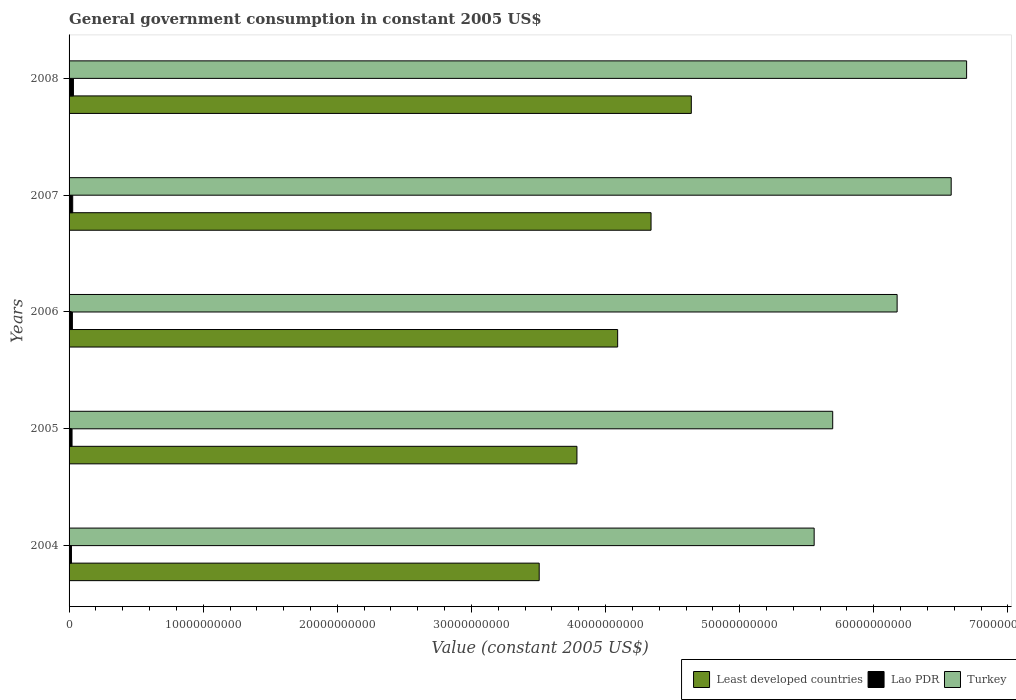How many different coloured bars are there?
Provide a short and direct response. 3. How many groups of bars are there?
Your answer should be very brief. 5. Are the number of bars on each tick of the Y-axis equal?
Your answer should be very brief. Yes. How many bars are there on the 4th tick from the bottom?
Provide a short and direct response. 3. What is the label of the 5th group of bars from the top?
Make the answer very short. 2004. In how many cases, is the number of bars for a given year not equal to the number of legend labels?
Your answer should be very brief. 0. What is the government conusmption in Least developed countries in 2004?
Give a very brief answer. 3.51e+1. Across all years, what is the maximum government conusmption in Least developed countries?
Make the answer very short. 4.64e+1. Across all years, what is the minimum government conusmption in Turkey?
Offer a very short reply. 5.56e+1. In which year was the government conusmption in Least developed countries maximum?
Offer a terse response. 2008. What is the total government conusmption in Turkey in the graph?
Ensure brevity in your answer.  3.07e+11. What is the difference between the government conusmption in Turkey in 2004 and that in 2008?
Your answer should be compact. -1.14e+1. What is the difference between the government conusmption in Least developed countries in 2004 and the government conusmption in Lao PDR in 2008?
Keep it short and to the point. 3.47e+1. What is the average government conusmption in Least developed countries per year?
Offer a terse response. 4.07e+1. In the year 2006, what is the difference between the government conusmption in Turkey and government conusmption in Least developed countries?
Ensure brevity in your answer.  2.08e+1. In how many years, is the government conusmption in Lao PDR greater than 6000000000 US$?
Your response must be concise. 0. What is the ratio of the government conusmption in Least developed countries in 2006 to that in 2007?
Make the answer very short. 0.94. What is the difference between the highest and the second highest government conusmption in Turkey?
Your answer should be very brief. 1.15e+09. What is the difference between the highest and the lowest government conusmption in Lao PDR?
Give a very brief answer. 1.46e+08. In how many years, is the government conusmption in Lao PDR greater than the average government conusmption in Lao PDR taken over all years?
Your answer should be very brief. 2. Is the sum of the government conusmption in Turkey in 2005 and 2008 greater than the maximum government conusmption in Least developed countries across all years?
Provide a succinct answer. Yes. What does the 3rd bar from the top in 2005 represents?
Provide a short and direct response. Least developed countries. What does the 1st bar from the bottom in 2004 represents?
Your response must be concise. Least developed countries. Is it the case that in every year, the sum of the government conusmption in Turkey and government conusmption in Least developed countries is greater than the government conusmption in Lao PDR?
Ensure brevity in your answer.  Yes. How many bars are there?
Provide a succinct answer. 15. What is the title of the graph?
Make the answer very short. General government consumption in constant 2005 US$. What is the label or title of the X-axis?
Your answer should be compact. Value (constant 2005 US$). What is the label or title of the Y-axis?
Give a very brief answer. Years. What is the Value (constant 2005 US$) in Least developed countries in 2004?
Make the answer very short. 3.51e+1. What is the Value (constant 2005 US$) in Lao PDR in 2004?
Provide a short and direct response. 1.79e+08. What is the Value (constant 2005 US$) in Turkey in 2004?
Offer a terse response. 5.56e+1. What is the Value (constant 2005 US$) of Least developed countries in 2005?
Make the answer very short. 3.79e+1. What is the Value (constant 2005 US$) of Lao PDR in 2005?
Give a very brief answer. 2.22e+08. What is the Value (constant 2005 US$) of Turkey in 2005?
Give a very brief answer. 5.69e+1. What is the Value (constant 2005 US$) of Least developed countries in 2006?
Your answer should be very brief. 4.09e+1. What is the Value (constant 2005 US$) in Lao PDR in 2006?
Keep it short and to the point. 2.48e+08. What is the Value (constant 2005 US$) of Turkey in 2006?
Offer a very short reply. 6.17e+1. What is the Value (constant 2005 US$) of Least developed countries in 2007?
Offer a terse response. 4.34e+1. What is the Value (constant 2005 US$) in Lao PDR in 2007?
Keep it short and to the point. 2.70e+08. What is the Value (constant 2005 US$) in Turkey in 2007?
Offer a very short reply. 6.58e+1. What is the Value (constant 2005 US$) of Least developed countries in 2008?
Ensure brevity in your answer.  4.64e+1. What is the Value (constant 2005 US$) of Lao PDR in 2008?
Your answer should be very brief. 3.25e+08. What is the Value (constant 2005 US$) in Turkey in 2008?
Your answer should be very brief. 6.69e+1. Across all years, what is the maximum Value (constant 2005 US$) of Least developed countries?
Your answer should be compact. 4.64e+1. Across all years, what is the maximum Value (constant 2005 US$) in Lao PDR?
Provide a short and direct response. 3.25e+08. Across all years, what is the maximum Value (constant 2005 US$) of Turkey?
Your answer should be very brief. 6.69e+1. Across all years, what is the minimum Value (constant 2005 US$) of Least developed countries?
Offer a very short reply. 3.51e+1. Across all years, what is the minimum Value (constant 2005 US$) in Lao PDR?
Ensure brevity in your answer.  1.79e+08. Across all years, what is the minimum Value (constant 2005 US$) of Turkey?
Give a very brief answer. 5.56e+1. What is the total Value (constant 2005 US$) of Least developed countries in the graph?
Give a very brief answer. 2.04e+11. What is the total Value (constant 2005 US$) of Lao PDR in the graph?
Your answer should be very brief. 1.24e+09. What is the total Value (constant 2005 US$) of Turkey in the graph?
Provide a short and direct response. 3.07e+11. What is the difference between the Value (constant 2005 US$) in Least developed countries in 2004 and that in 2005?
Offer a terse response. -2.81e+09. What is the difference between the Value (constant 2005 US$) in Lao PDR in 2004 and that in 2005?
Offer a very short reply. -4.29e+07. What is the difference between the Value (constant 2005 US$) of Turkey in 2004 and that in 2005?
Your answer should be very brief. -1.38e+09. What is the difference between the Value (constant 2005 US$) of Least developed countries in 2004 and that in 2006?
Your response must be concise. -5.85e+09. What is the difference between the Value (constant 2005 US$) of Lao PDR in 2004 and that in 2006?
Your response must be concise. -6.93e+07. What is the difference between the Value (constant 2005 US$) of Turkey in 2004 and that in 2006?
Give a very brief answer. -6.19e+09. What is the difference between the Value (constant 2005 US$) of Least developed countries in 2004 and that in 2007?
Give a very brief answer. -8.34e+09. What is the difference between the Value (constant 2005 US$) of Lao PDR in 2004 and that in 2007?
Give a very brief answer. -9.17e+07. What is the difference between the Value (constant 2005 US$) in Turkey in 2004 and that in 2007?
Ensure brevity in your answer.  -1.02e+1. What is the difference between the Value (constant 2005 US$) in Least developed countries in 2004 and that in 2008?
Your answer should be very brief. -1.13e+1. What is the difference between the Value (constant 2005 US$) in Lao PDR in 2004 and that in 2008?
Provide a short and direct response. -1.46e+08. What is the difference between the Value (constant 2005 US$) of Turkey in 2004 and that in 2008?
Ensure brevity in your answer.  -1.14e+1. What is the difference between the Value (constant 2005 US$) of Least developed countries in 2005 and that in 2006?
Give a very brief answer. -3.04e+09. What is the difference between the Value (constant 2005 US$) of Lao PDR in 2005 and that in 2006?
Provide a short and direct response. -2.64e+07. What is the difference between the Value (constant 2005 US$) of Turkey in 2005 and that in 2006?
Ensure brevity in your answer.  -4.80e+09. What is the difference between the Value (constant 2005 US$) of Least developed countries in 2005 and that in 2007?
Your answer should be compact. -5.53e+09. What is the difference between the Value (constant 2005 US$) in Lao PDR in 2005 and that in 2007?
Your response must be concise. -4.88e+07. What is the difference between the Value (constant 2005 US$) of Turkey in 2005 and that in 2007?
Give a very brief answer. -8.83e+09. What is the difference between the Value (constant 2005 US$) of Least developed countries in 2005 and that in 2008?
Make the answer very short. -8.53e+09. What is the difference between the Value (constant 2005 US$) of Lao PDR in 2005 and that in 2008?
Your answer should be compact. -1.03e+08. What is the difference between the Value (constant 2005 US$) in Turkey in 2005 and that in 2008?
Provide a short and direct response. -9.98e+09. What is the difference between the Value (constant 2005 US$) of Least developed countries in 2006 and that in 2007?
Your answer should be very brief. -2.49e+09. What is the difference between the Value (constant 2005 US$) of Lao PDR in 2006 and that in 2007?
Provide a succinct answer. -2.24e+07. What is the difference between the Value (constant 2005 US$) of Turkey in 2006 and that in 2007?
Ensure brevity in your answer.  -4.03e+09. What is the difference between the Value (constant 2005 US$) in Least developed countries in 2006 and that in 2008?
Ensure brevity in your answer.  -5.49e+09. What is the difference between the Value (constant 2005 US$) in Lao PDR in 2006 and that in 2008?
Give a very brief answer. -7.70e+07. What is the difference between the Value (constant 2005 US$) in Turkey in 2006 and that in 2008?
Your answer should be compact. -5.18e+09. What is the difference between the Value (constant 2005 US$) of Least developed countries in 2007 and that in 2008?
Your answer should be very brief. -3.00e+09. What is the difference between the Value (constant 2005 US$) of Lao PDR in 2007 and that in 2008?
Provide a short and direct response. -5.46e+07. What is the difference between the Value (constant 2005 US$) in Turkey in 2007 and that in 2008?
Make the answer very short. -1.15e+09. What is the difference between the Value (constant 2005 US$) in Least developed countries in 2004 and the Value (constant 2005 US$) in Lao PDR in 2005?
Give a very brief answer. 3.48e+1. What is the difference between the Value (constant 2005 US$) of Least developed countries in 2004 and the Value (constant 2005 US$) of Turkey in 2005?
Provide a succinct answer. -2.19e+1. What is the difference between the Value (constant 2005 US$) in Lao PDR in 2004 and the Value (constant 2005 US$) in Turkey in 2005?
Your answer should be compact. -5.68e+1. What is the difference between the Value (constant 2005 US$) in Least developed countries in 2004 and the Value (constant 2005 US$) in Lao PDR in 2006?
Offer a terse response. 3.48e+1. What is the difference between the Value (constant 2005 US$) of Least developed countries in 2004 and the Value (constant 2005 US$) of Turkey in 2006?
Offer a terse response. -2.67e+1. What is the difference between the Value (constant 2005 US$) in Lao PDR in 2004 and the Value (constant 2005 US$) in Turkey in 2006?
Ensure brevity in your answer.  -6.16e+1. What is the difference between the Value (constant 2005 US$) of Least developed countries in 2004 and the Value (constant 2005 US$) of Lao PDR in 2007?
Keep it short and to the point. 3.48e+1. What is the difference between the Value (constant 2005 US$) in Least developed countries in 2004 and the Value (constant 2005 US$) in Turkey in 2007?
Your response must be concise. -3.07e+1. What is the difference between the Value (constant 2005 US$) of Lao PDR in 2004 and the Value (constant 2005 US$) of Turkey in 2007?
Give a very brief answer. -6.56e+1. What is the difference between the Value (constant 2005 US$) in Least developed countries in 2004 and the Value (constant 2005 US$) in Lao PDR in 2008?
Your answer should be very brief. 3.47e+1. What is the difference between the Value (constant 2005 US$) in Least developed countries in 2004 and the Value (constant 2005 US$) in Turkey in 2008?
Provide a succinct answer. -3.19e+1. What is the difference between the Value (constant 2005 US$) in Lao PDR in 2004 and the Value (constant 2005 US$) in Turkey in 2008?
Provide a short and direct response. -6.67e+1. What is the difference between the Value (constant 2005 US$) in Least developed countries in 2005 and the Value (constant 2005 US$) in Lao PDR in 2006?
Your response must be concise. 3.76e+1. What is the difference between the Value (constant 2005 US$) of Least developed countries in 2005 and the Value (constant 2005 US$) of Turkey in 2006?
Make the answer very short. -2.39e+1. What is the difference between the Value (constant 2005 US$) in Lao PDR in 2005 and the Value (constant 2005 US$) in Turkey in 2006?
Keep it short and to the point. -6.15e+1. What is the difference between the Value (constant 2005 US$) in Least developed countries in 2005 and the Value (constant 2005 US$) in Lao PDR in 2007?
Offer a very short reply. 3.76e+1. What is the difference between the Value (constant 2005 US$) in Least developed countries in 2005 and the Value (constant 2005 US$) in Turkey in 2007?
Provide a short and direct response. -2.79e+1. What is the difference between the Value (constant 2005 US$) of Lao PDR in 2005 and the Value (constant 2005 US$) of Turkey in 2007?
Your response must be concise. -6.55e+1. What is the difference between the Value (constant 2005 US$) of Least developed countries in 2005 and the Value (constant 2005 US$) of Lao PDR in 2008?
Provide a short and direct response. 3.75e+1. What is the difference between the Value (constant 2005 US$) of Least developed countries in 2005 and the Value (constant 2005 US$) of Turkey in 2008?
Make the answer very short. -2.91e+1. What is the difference between the Value (constant 2005 US$) in Lao PDR in 2005 and the Value (constant 2005 US$) in Turkey in 2008?
Your response must be concise. -6.67e+1. What is the difference between the Value (constant 2005 US$) of Least developed countries in 2006 and the Value (constant 2005 US$) of Lao PDR in 2007?
Your answer should be compact. 4.06e+1. What is the difference between the Value (constant 2005 US$) in Least developed countries in 2006 and the Value (constant 2005 US$) in Turkey in 2007?
Your answer should be compact. -2.49e+1. What is the difference between the Value (constant 2005 US$) of Lao PDR in 2006 and the Value (constant 2005 US$) of Turkey in 2007?
Your answer should be very brief. -6.55e+1. What is the difference between the Value (constant 2005 US$) in Least developed countries in 2006 and the Value (constant 2005 US$) in Lao PDR in 2008?
Your answer should be compact. 4.06e+1. What is the difference between the Value (constant 2005 US$) of Least developed countries in 2006 and the Value (constant 2005 US$) of Turkey in 2008?
Provide a succinct answer. -2.60e+1. What is the difference between the Value (constant 2005 US$) of Lao PDR in 2006 and the Value (constant 2005 US$) of Turkey in 2008?
Offer a terse response. -6.67e+1. What is the difference between the Value (constant 2005 US$) of Least developed countries in 2007 and the Value (constant 2005 US$) of Lao PDR in 2008?
Give a very brief answer. 4.31e+1. What is the difference between the Value (constant 2005 US$) in Least developed countries in 2007 and the Value (constant 2005 US$) in Turkey in 2008?
Your answer should be compact. -2.35e+1. What is the difference between the Value (constant 2005 US$) in Lao PDR in 2007 and the Value (constant 2005 US$) in Turkey in 2008?
Offer a very short reply. -6.66e+1. What is the average Value (constant 2005 US$) of Least developed countries per year?
Your answer should be very brief. 4.07e+1. What is the average Value (constant 2005 US$) in Lao PDR per year?
Provide a short and direct response. 2.49e+08. What is the average Value (constant 2005 US$) of Turkey per year?
Give a very brief answer. 6.14e+1. In the year 2004, what is the difference between the Value (constant 2005 US$) in Least developed countries and Value (constant 2005 US$) in Lao PDR?
Give a very brief answer. 3.49e+1. In the year 2004, what is the difference between the Value (constant 2005 US$) in Least developed countries and Value (constant 2005 US$) in Turkey?
Your answer should be compact. -2.05e+1. In the year 2004, what is the difference between the Value (constant 2005 US$) of Lao PDR and Value (constant 2005 US$) of Turkey?
Provide a short and direct response. -5.54e+1. In the year 2005, what is the difference between the Value (constant 2005 US$) of Least developed countries and Value (constant 2005 US$) of Lao PDR?
Keep it short and to the point. 3.76e+1. In the year 2005, what is the difference between the Value (constant 2005 US$) of Least developed countries and Value (constant 2005 US$) of Turkey?
Your answer should be compact. -1.91e+1. In the year 2005, what is the difference between the Value (constant 2005 US$) of Lao PDR and Value (constant 2005 US$) of Turkey?
Ensure brevity in your answer.  -5.67e+1. In the year 2006, what is the difference between the Value (constant 2005 US$) in Least developed countries and Value (constant 2005 US$) in Lao PDR?
Your answer should be compact. 4.07e+1. In the year 2006, what is the difference between the Value (constant 2005 US$) in Least developed countries and Value (constant 2005 US$) in Turkey?
Your answer should be compact. -2.08e+1. In the year 2006, what is the difference between the Value (constant 2005 US$) of Lao PDR and Value (constant 2005 US$) of Turkey?
Give a very brief answer. -6.15e+1. In the year 2007, what is the difference between the Value (constant 2005 US$) of Least developed countries and Value (constant 2005 US$) of Lao PDR?
Your answer should be compact. 4.31e+1. In the year 2007, what is the difference between the Value (constant 2005 US$) of Least developed countries and Value (constant 2005 US$) of Turkey?
Provide a short and direct response. -2.24e+1. In the year 2007, what is the difference between the Value (constant 2005 US$) of Lao PDR and Value (constant 2005 US$) of Turkey?
Offer a very short reply. -6.55e+1. In the year 2008, what is the difference between the Value (constant 2005 US$) in Least developed countries and Value (constant 2005 US$) in Lao PDR?
Make the answer very short. 4.61e+1. In the year 2008, what is the difference between the Value (constant 2005 US$) in Least developed countries and Value (constant 2005 US$) in Turkey?
Make the answer very short. -2.05e+1. In the year 2008, what is the difference between the Value (constant 2005 US$) of Lao PDR and Value (constant 2005 US$) of Turkey?
Provide a succinct answer. -6.66e+1. What is the ratio of the Value (constant 2005 US$) in Least developed countries in 2004 to that in 2005?
Your answer should be compact. 0.93. What is the ratio of the Value (constant 2005 US$) of Lao PDR in 2004 to that in 2005?
Make the answer very short. 0.81. What is the ratio of the Value (constant 2005 US$) of Turkey in 2004 to that in 2005?
Your response must be concise. 0.98. What is the ratio of the Value (constant 2005 US$) in Least developed countries in 2004 to that in 2006?
Make the answer very short. 0.86. What is the ratio of the Value (constant 2005 US$) of Lao PDR in 2004 to that in 2006?
Your answer should be very brief. 0.72. What is the ratio of the Value (constant 2005 US$) in Turkey in 2004 to that in 2006?
Provide a short and direct response. 0.9. What is the ratio of the Value (constant 2005 US$) of Least developed countries in 2004 to that in 2007?
Offer a very short reply. 0.81. What is the ratio of the Value (constant 2005 US$) in Lao PDR in 2004 to that in 2007?
Make the answer very short. 0.66. What is the ratio of the Value (constant 2005 US$) in Turkey in 2004 to that in 2007?
Your answer should be very brief. 0.84. What is the ratio of the Value (constant 2005 US$) in Least developed countries in 2004 to that in 2008?
Give a very brief answer. 0.76. What is the ratio of the Value (constant 2005 US$) of Lao PDR in 2004 to that in 2008?
Your answer should be compact. 0.55. What is the ratio of the Value (constant 2005 US$) of Turkey in 2004 to that in 2008?
Offer a terse response. 0.83. What is the ratio of the Value (constant 2005 US$) in Least developed countries in 2005 to that in 2006?
Offer a terse response. 0.93. What is the ratio of the Value (constant 2005 US$) in Lao PDR in 2005 to that in 2006?
Keep it short and to the point. 0.89. What is the ratio of the Value (constant 2005 US$) in Turkey in 2005 to that in 2006?
Make the answer very short. 0.92. What is the ratio of the Value (constant 2005 US$) in Least developed countries in 2005 to that in 2007?
Keep it short and to the point. 0.87. What is the ratio of the Value (constant 2005 US$) of Lao PDR in 2005 to that in 2007?
Ensure brevity in your answer.  0.82. What is the ratio of the Value (constant 2005 US$) of Turkey in 2005 to that in 2007?
Your answer should be compact. 0.87. What is the ratio of the Value (constant 2005 US$) of Least developed countries in 2005 to that in 2008?
Your response must be concise. 0.82. What is the ratio of the Value (constant 2005 US$) of Lao PDR in 2005 to that in 2008?
Your response must be concise. 0.68. What is the ratio of the Value (constant 2005 US$) in Turkey in 2005 to that in 2008?
Offer a very short reply. 0.85. What is the ratio of the Value (constant 2005 US$) in Least developed countries in 2006 to that in 2007?
Offer a terse response. 0.94. What is the ratio of the Value (constant 2005 US$) in Lao PDR in 2006 to that in 2007?
Keep it short and to the point. 0.92. What is the ratio of the Value (constant 2005 US$) in Turkey in 2006 to that in 2007?
Give a very brief answer. 0.94. What is the ratio of the Value (constant 2005 US$) of Least developed countries in 2006 to that in 2008?
Give a very brief answer. 0.88. What is the ratio of the Value (constant 2005 US$) of Lao PDR in 2006 to that in 2008?
Offer a very short reply. 0.76. What is the ratio of the Value (constant 2005 US$) of Turkey in 2006 to that in 2008?
Your response must be concise. 0.92. What is the ratio of the Value (constant 2005 US$) in Least developed countries in 2007 to that in 2008?
Offer a very short reply. 0.94. What is the ratio of the Value (constant 2005 US$) in Lao PDR in 2007 to that in 2008?
Make the answer very short. 0.83. What is the ratio of the Value (constant 2005 US$) in Turkey in 2007 to that in 2008?
Provide a succinct answer. 0.98. What is the difference between the highest and the second highest Value (constant 2005 US$) in Least developed countries?
Your answer should be very brief. 3.00e+09. What is the difference between the highest and the second highest Value (constant 2005 US$) of Lao PDR?
Ensure brevity in your answer.  5.46e+07. What is the difference between the highest and the second highest Value (constant 2005 US$) in Turkey?
Make the answer very short. 1.15e+09. What is the difference between the highest and the lowest Value (constant 2005 US$) in Least developed countries?
Your response must be concise. 1.13e+1. What is the difference between the highest and the lowest Value (constant 2005 US$) of Lao PDR?
Ensure brevity in your answer.  1.46e+08. What is the difference between the highest and the lowest Value (constant 2005 US$) of Turkey?
Make the answer very short. 1.14e+1. 